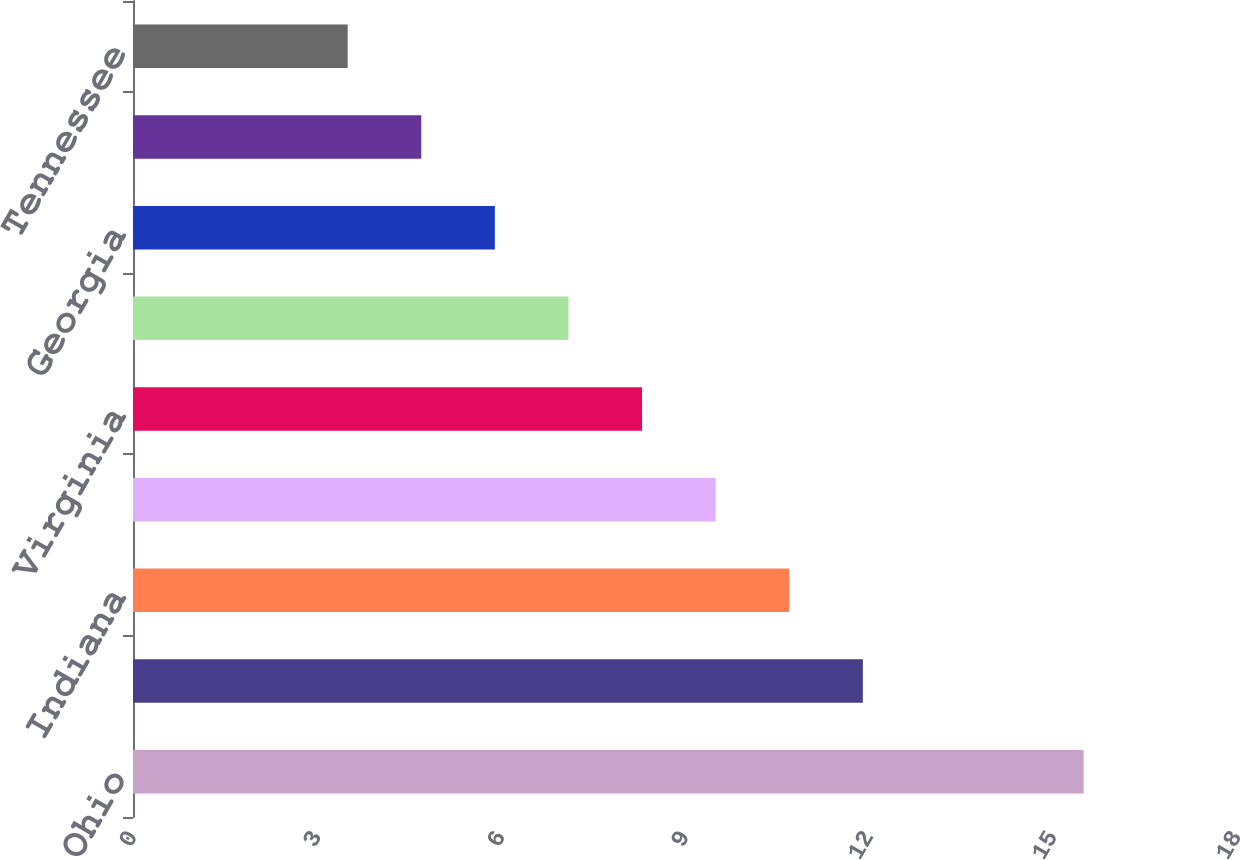<chart> <loc_0><loc_0><loc_500><loc_500><bar_chart><fcel>Ohio<fcel>Pennsylvania<fcel>Indiana<fcel>North Carolina<fcel>Virginia<fcel>Michigan<fcel>Georgia<fcel>Wisconsin<fcel>Tennessee<nl><fcel>15.5<fcel>11.9<fcel>10.7<fcel>9.5<fcel>8.3<fcel>7.1<fcel>5.9<fcel>4.7<fcel>3.5<nl></chart> 